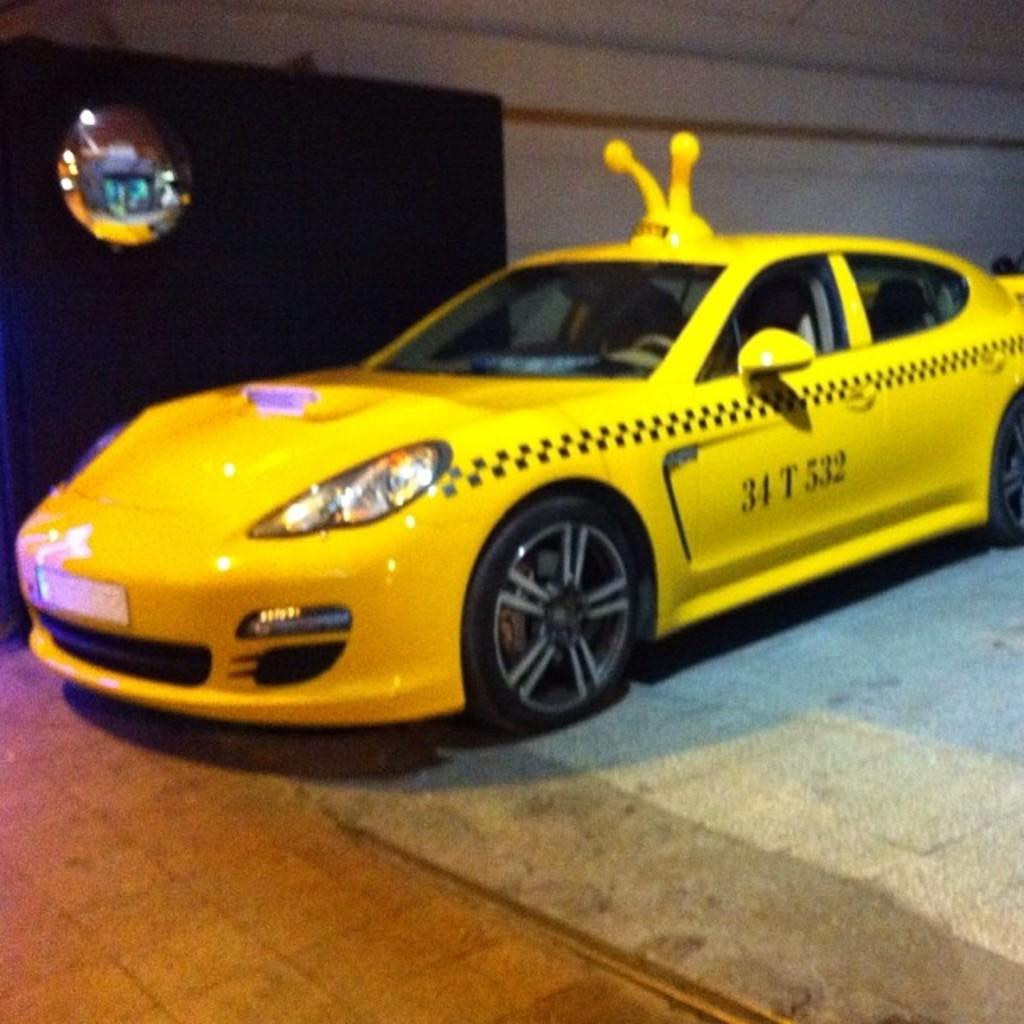What are the numbers on the side of the car?
Offer a terse response. 34 t 532. 